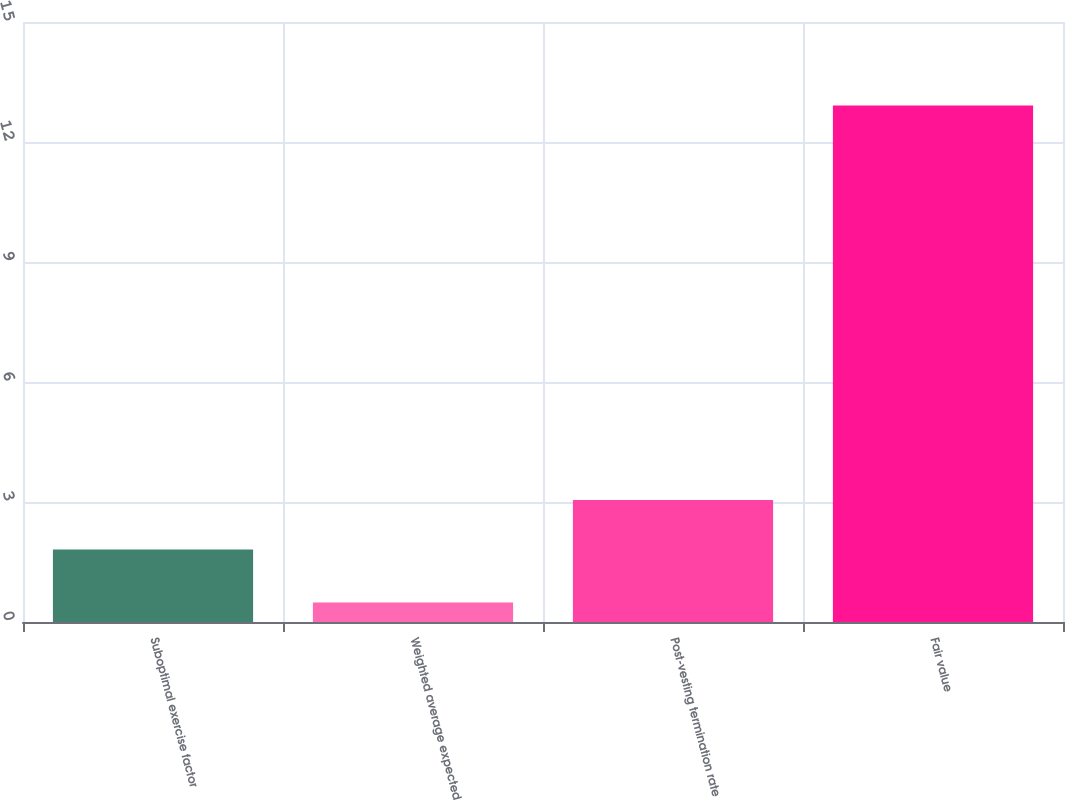Convert chart to OTSL. <chart><loc_0><loc_0><loc_500><loc_500><bar_chart><fcel>Suboptimal exercise factor<fcel>Weighted average expected<fcel>Post-vesting termination rate<fcel>Fair value<nl><fcel>1.81<fcel>0.49<fcel>3.05<fcel>12.91<nl></chart> 